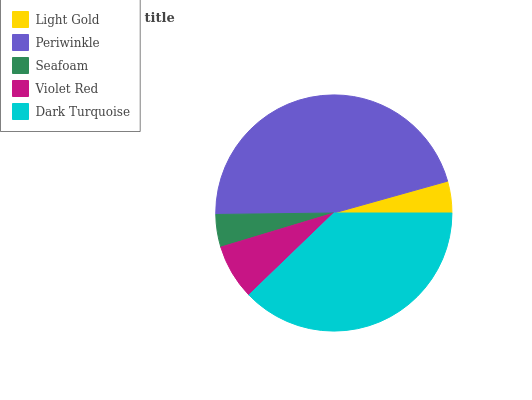Is Light Gold the minimum?
Answer yes or no. Yes. Is Periwinkle the maximum?
Answer yes or no. Yes. Is Seafoam the minimum?
Answer yes or no. No. Is Seafoam the maximum?
Answer yes or no. No. Is Periwinkle greater than Seafoam?
Answer yes or no. Yes. Is Seafoam less than Periwinkle?
Answer yes or no. Yes. Is Seafoam greater than Periwinkle?
Answer yes or no. No. Is Periwinkle less than Seafoam?
Answer yes or no. No. Is Violet Red the high median?
Answer yes or no. Yes. Is Violet Red the low median?
Answer yes or no. Yes. Is Dark Turquoise the high median?
Answer yes or no. No. Is Seafoam the low median?
Answer yes or no. No. 